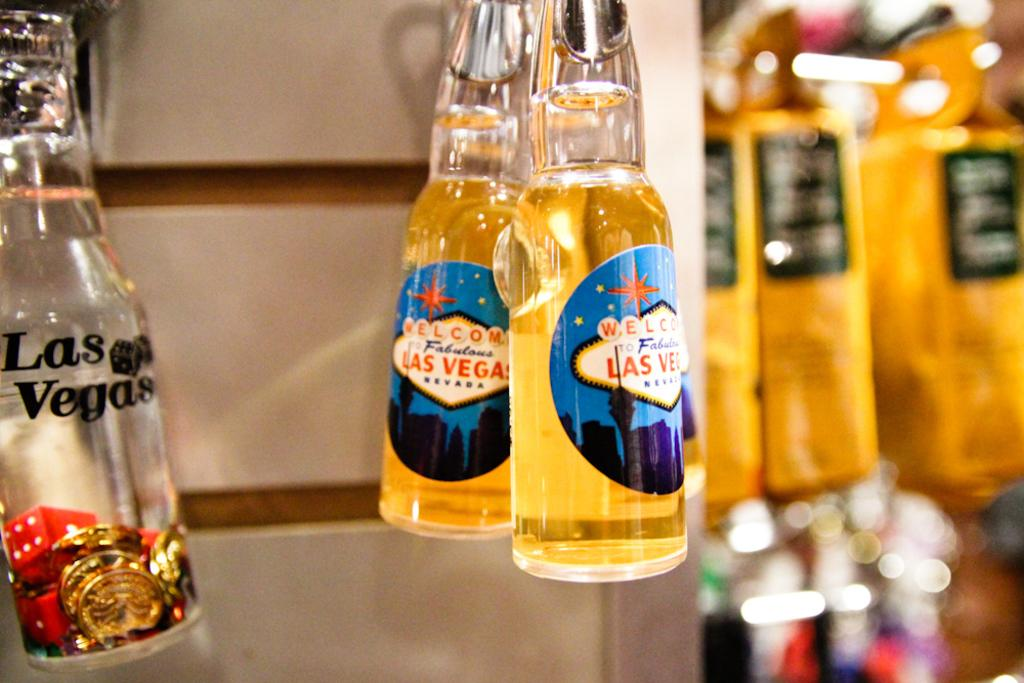<image>
Create a compact narrative representing the image presented. Glass bottles with different Las Vegas themed designs 